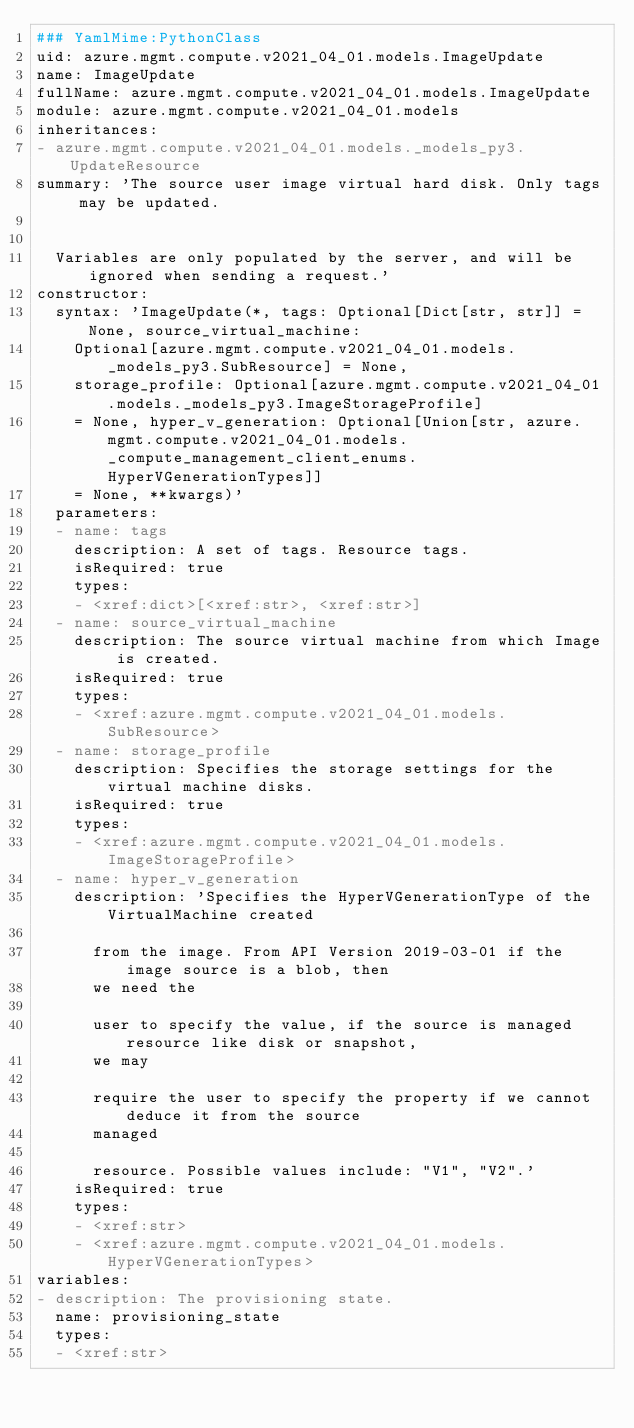<code> <loc_0><loc_0><loc_500><loc_500><_YAML_>### YamlMime:PythonClass
uid: azure.mgmt.compute.v2021_04_01.models.ImageUpdate
name: ImageUpdate
fullName: azure.mgmt.compute.v2021_04_01.models.ImageUpdate
module: azure.mgmt.compute.v2021_04_01.models
inheritances:
- azure.mgmt.compute.v2021_04_01.models._models_py3.UpdateResource
summary: 'The source user image virtual hard disk. Only tags may be updated.


  Variables are only populated by the server, and will be ignored when sending a request.'
constructor:
  syntax: 'ImageUpdate(*, tags: Optional[Dict[str, str]] = None, source_virtual_machine:
    Optional[azure.mgmt.compute.v2021_04_01.models._models_py3.SubResource] = None,
    storage_profile: Optional[azure.mgmt.compute.v2021_04_01.models._models_py3.ImageStorageProfile]
    = None, hyper_v_generation: Optional[Union[str, azure.mgmt.compute.v2021_04_01.models._compute_management_client_enums.HyperVGenerationTypes]]
    = None, **kwargs)'
  parameters:
  - name: tags
    description: A set of tags. Resource tags.
    isRequired: true
    types:
    - <xref:dict>[<xref:str>, <xref:str>]
  - name: source_virtual_machine
    description: The source virtual machine from which Image is created.
    isRequired: true
    types:
    - <xref:azure.mgmt.compute.v2021_04_01.models.SubResource>
  - name: storage_profile
    description: Specifies the storage settings for the virtual machine disks.
    isRequired: true
    types:
    - <xref:azure.mgmt.compute.v2021_04_01.models.ImageStorageProfile>
  - name: hyper_v_generation
    description: 'Specifies the HyperVGenerationType of the VirtualMachine created

      from the image. From API Version 2019-03-01 if the image source is a blob, then
      we need the

      user to specify the value, if the source is managed resource like disk or snapshot,
      we may

      require the user to specify the property if we cannot deduce it from the source
      managed

      resource. Possible values include: "V1", "V2".'
    isRequired: true
    types:
    - <xref:str>
    - <xref:azure.mgmt.compute.v2021_04_01.models.HyperVGenerationTypes>
variables:
- description: The provisioning state.
  name: provisioning_state
  types:
  - <xref:str>
</code> 